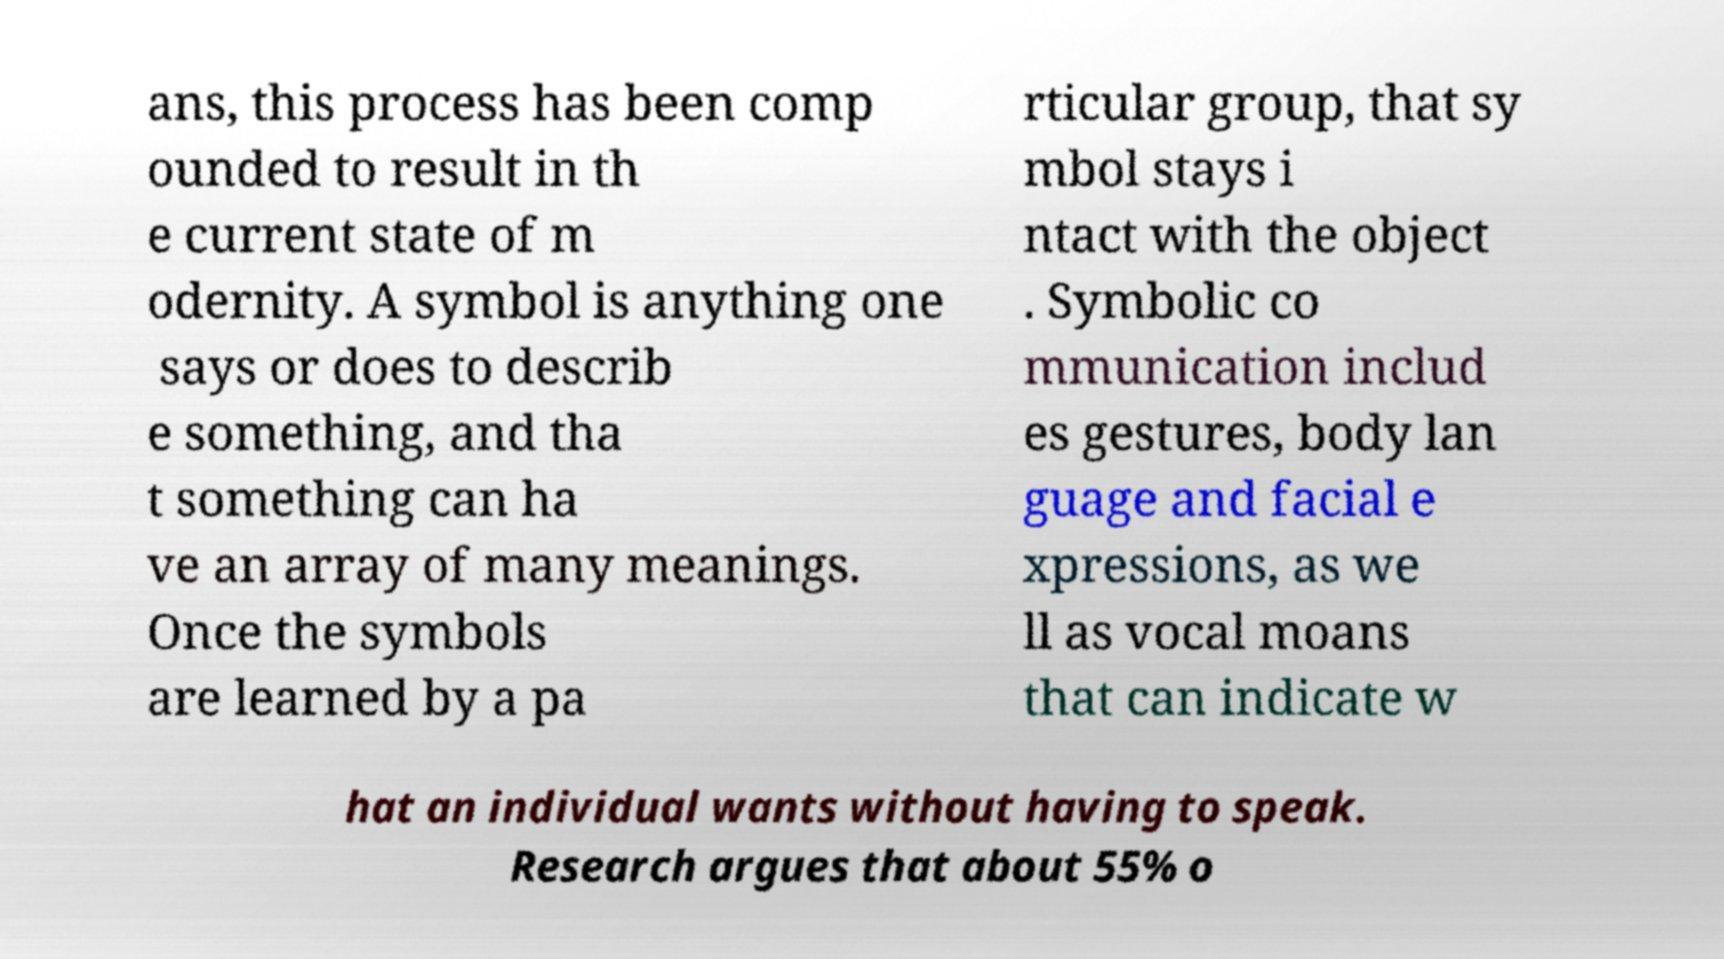Could you assist in decoding the text presented in this image and type it out clearly? ans, this process has been comp ounded to result in th e current state of m odernity. A symbol is anything one says or does to describ e something, and tha t something can ha ve an array of many meanings. Once the symbols are learned by a pa rticular group, that sy mbol stays i ntact with the object . Symbolic co mmunication includ es gestures, body lan guage and facial e xpressions, as we ll as vocal moans that can indicate w hat an individual wants without having to speak. Research argues that about 55% o 